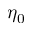Convert formula to latex. <formula><loc_0><loc_0><loc_500><loc_500>\eta _ { 0 }</formula> 